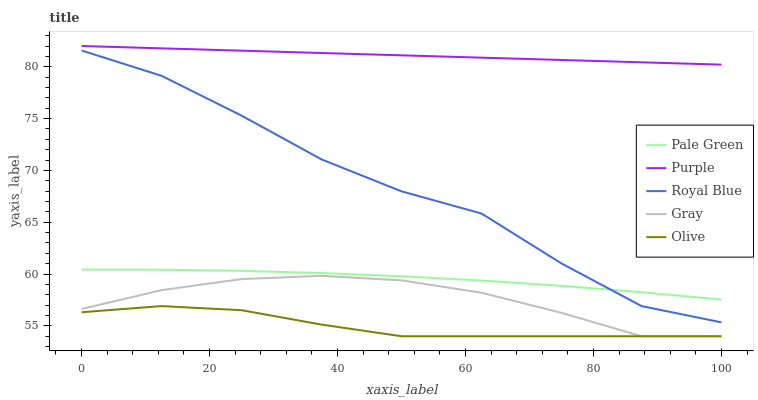Does Olive have the minimum area under the curve?
Answer yes or no. Yes. Does Purple have the maximum area under the curve?
Answer yes or no. Yes. Does Royal Blue have the minimum area under the curve?
Answer yes or no. No. Does Royal Blue have the maximum area under the curve?
Answer yes or no. No. Is Purple the smoothest?
Answer yes or no. Yes. Is Royal Blue the roughest?
Answer yes or no. Yes. Is Pale Green the smoothest?
Answer yes or no. No. Is Pale Green the roughest?
Answer yes or no. No. Does Olive have the lowest value?
Answer yes or no. Yes. Does Royal Blue have the lowest value?
Answer yes or no. No. Does Purple have the highest value?
Answer yes or no. Yes. Does Royal Blue have the highest value?
Answer yes or no. No. Is Royal Blue less than Purple?
Answer yes or no. Yes. Is Purple greater than Gray?
Answer yes or no. Yes. Does Olive intersect Gray?
Answer yes or no. Yes. Is Olive less than Gray?
Answer yes or no. No. Is Olive greater than Gray?
Answer yes or no. No. Does Royal Blue intersect Purple?
Answer yes or no. No. 